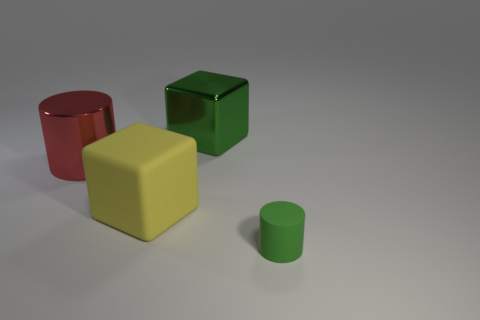Add 1 green objects. How many objects exist? 5 Add 3 large objects. How many large objects are left? 6 Add 4 big objects. How many big objects exist? 7 Subtract 0 brown cylinders. How many objects are left? 4 Subtract all gray balls. Subtract all large green blocks. How many objects are left? 3 